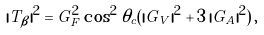<formula> <loc_0><loc_0><loc_500><loc_500>| T _ { \beta } | ^ { 2 } = G _ { F } ^ { 2 } \cos ^ { 2 } \theta _ { c } ( | G _ { V } | ^ { 2 } + 3 \, | G _ { A } | ^ { 2 } ) \, ,</formula> 